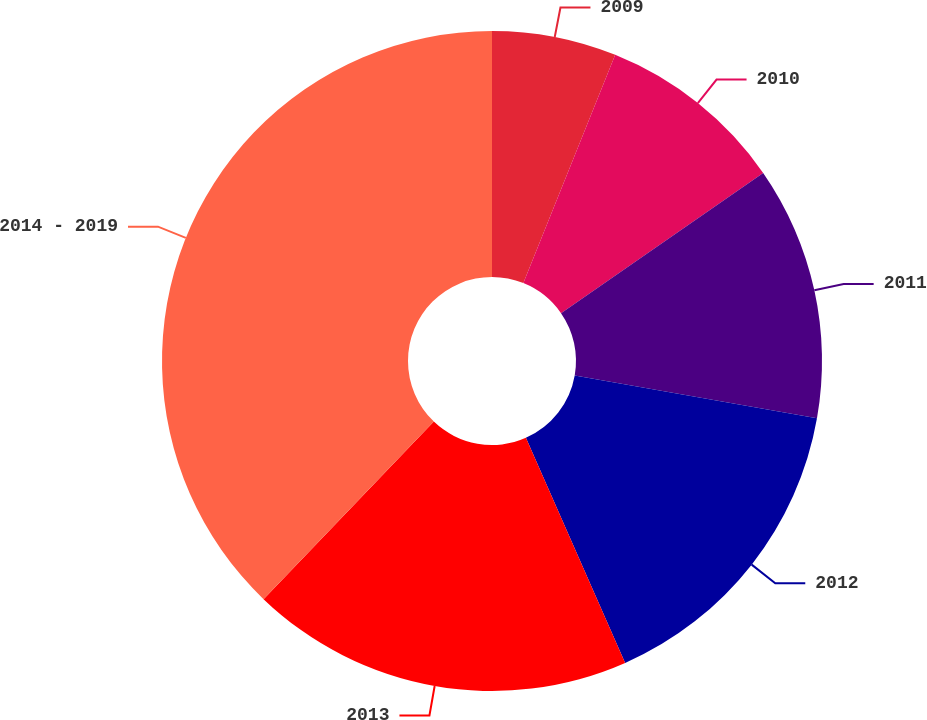<chart> <loc_0><loc_0><loc_500><loc_500><pie_chart><fcel>2009<fcel>2010<fcel>2011<fcel>2012<fcel>2013<fcel>2014 - 2019<nl><fcel>6.09%<fcel>9.26%<fcel>12.43%<fcel>15.61%<fcel>18.78%<fcel>37.83%<nl></chart> 